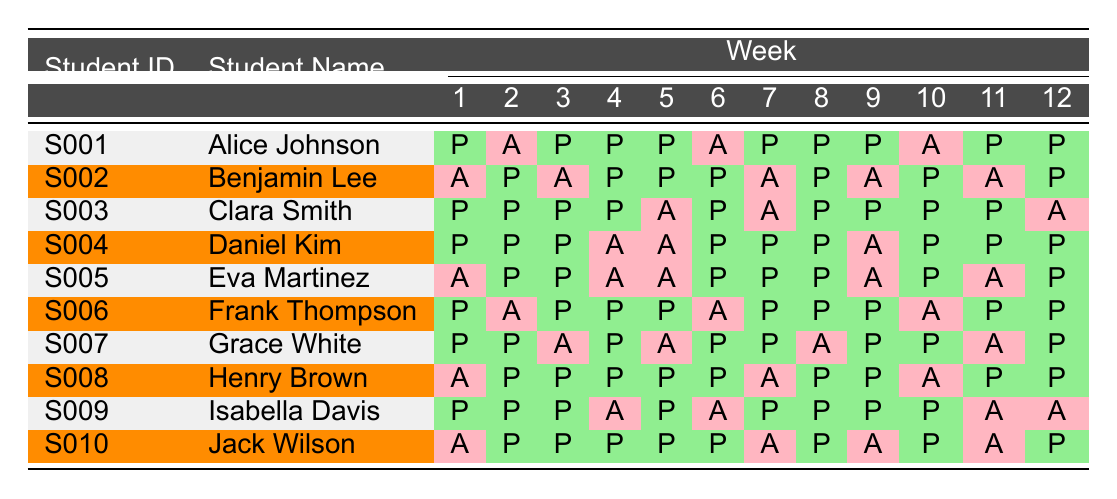What is the attendance status of Clara Smith in week 5? Clara Smith's attendance for week 5 is listed as "Absent" in the table.
Answer: Absent How many weeks did Benjamin Lee attend class? Counting the weeks where Benjamin Lee is marked as "Present", he attended a total of 7 weeks: weeks 2, 4, 5, 6, 8, 10, and 12.
Answer: 7 weeks Did Jack Wilson attend all classes in week 4? Jack Wilson's attendance in week 4 is "Present", which indicates he attended that class.
Answer: Yes Who attended class the most weeks? By comparing the attendance records, Clara Smith attended 10 weeks, which is the highest number of attendances among all students.
Answer: Clara Smith How many students were absent in week 10? In week 10, 4 students are marked as "Absent": Alice Johnson, Benjamin Lee, Eva Martinez, and Isabella Davis.
Answer: 4 students Which student had the highest number of absences? Analyzing the attendance records, Eva Martinez had the highest number of absences with a total of 6 weeks absent.
Answer: Eva Martinez What is the average number of weeks attended across all students? To find the average, add up each student's present weeks (total 69) and divide by the number of students (10), which results in an average of 6.9 weeks attended.
Answer: 6.9 weeks Is it true that Grace White attended more weeks than Eva Martinez? Grace White attended 7 weeks while Eva Martinez attended 6 weeks, making the statement true.
Answer: Yes How many students attended every class at least once? By examining the table, all students showed at least one "Present" attendance. Thus, all 10 students attended class at least once.
Answer: 10 students Who had the least amount of attendance in the semester? Evaluating the attendance records, Benjamin Lee had the least attendance with only 7 weeks marked as "Present".
Answer: Benjamin Lee 